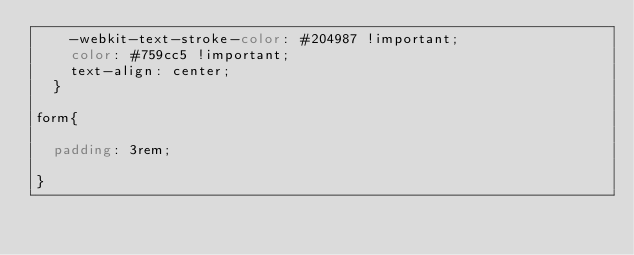<code> <loc_0><loc_0><loc_500><loc_500><_CSS_>    -webkit-text-stroke-color: #204987 !important;
    color: #759cc5 !important;
    text-align: center;
  }

form{

	padding: 3rem;

}



</code> 